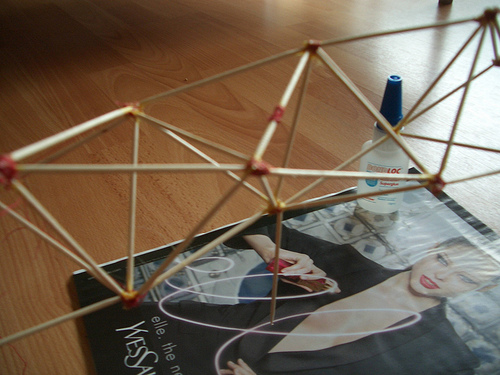<image>
Is the toothpicks above the magazine? Yes. The toothpicks is positioned above the magazine in the vertical space, higher up in the scene. 